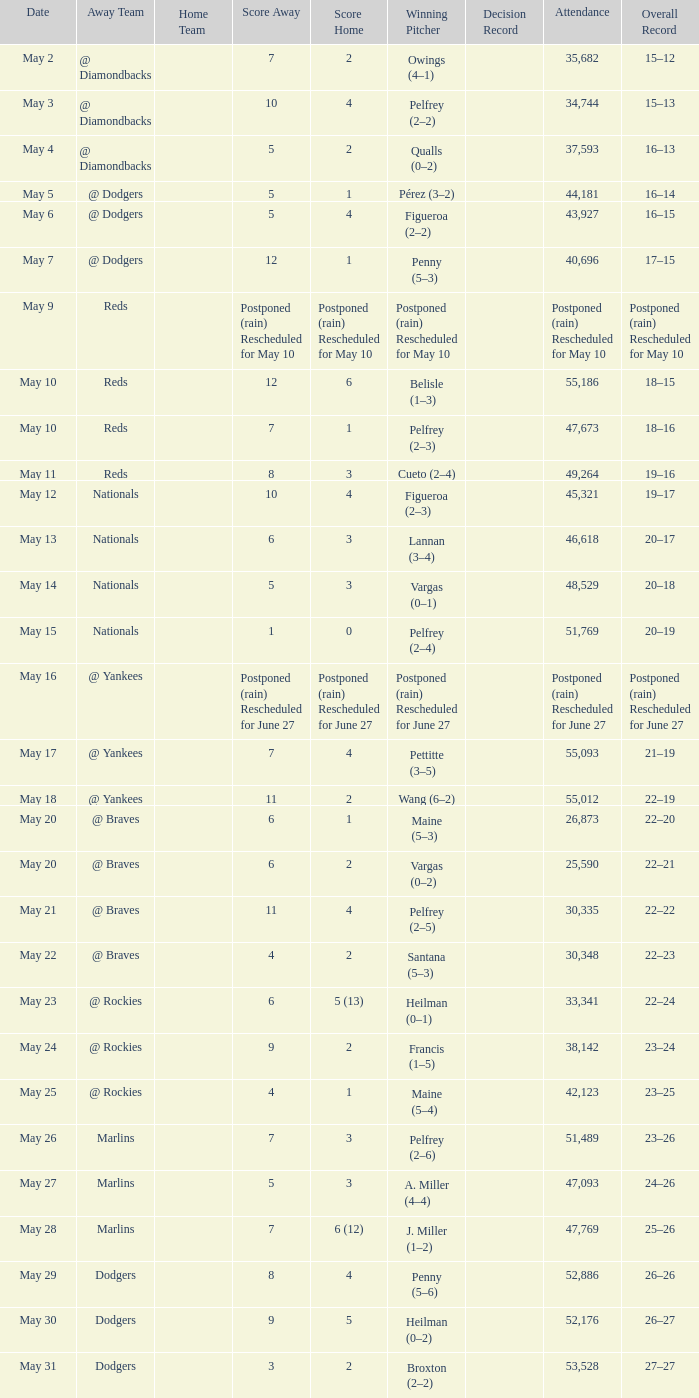Opponent of @ braves, and a Loss of pelfrey (2–5) had what score? 11–4. 